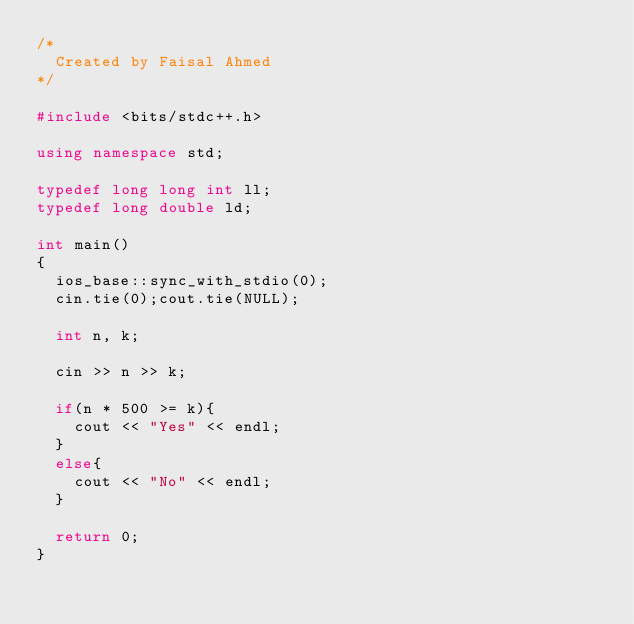Convert code to text. <code><loc_0><loc_0><loc_500><loc_500><_C++_>/*
	Created by Faisal Ahmed
*/

#include <bits/stdc++.h>
 
using namespace std;
 
typedef long long int ll;
typedef long double ld;

int main()
{
	ios_base::sync_with_stdio(0);
	cin.tie(0);cout.tie(NULL);
	
	int n, k;
	
	cin >> n >> k;
	
	if(n * 500 >= k){
		cout << "Yes" << endl;
	}
	else{
		cout << "No" << endl;
	}
	
	return 0;
} </code> 